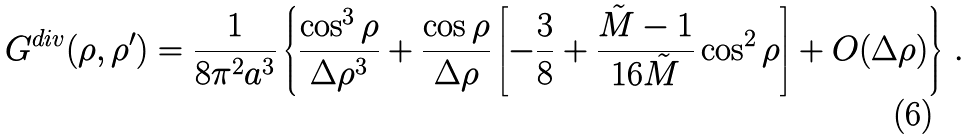<formula> <loc_0><loc_0><loc_500><loc_500>G ^ { d i v } ( \rho , \rho ^ { \prime } ) = \frac { 1 } { 8 \pi ^ { 2 } a ^ { 3 } } \left \{ \frac { \cos ^ { 3 } \rho } { \Delta \rho ^ { 3 } } + \frac { \cos \rho } { \Delta \rho } \left [ - \frac { 3 } { 8 } + \frac { \tilde { M } - 1 } { 1 6 \tilde { M } } \cos ^ { 2 } \rho \right ] + O ( \Delta \rho ) \right \} \, .</formula> 